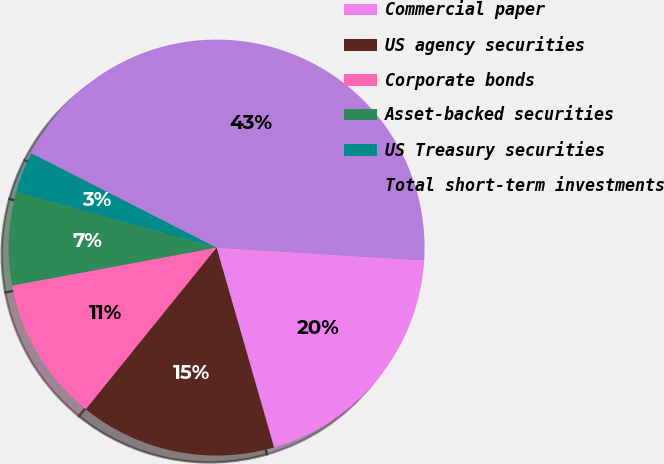<chart> <loc_0><loc_0><loc_500><loc_500><pie_chart><fcel>Commercial paper<fcel>US agency securities<fcel>Corporate bonds<fcel>Asset-backed securities<fcel>US Treasury securities<fcel>Total short-term investments<nl><fcel>19.57%<fcel>15.28%<fcel>11.25%<fcel>7.23%<fcel>3.2%<fcel>43.47%<nl></chart> 